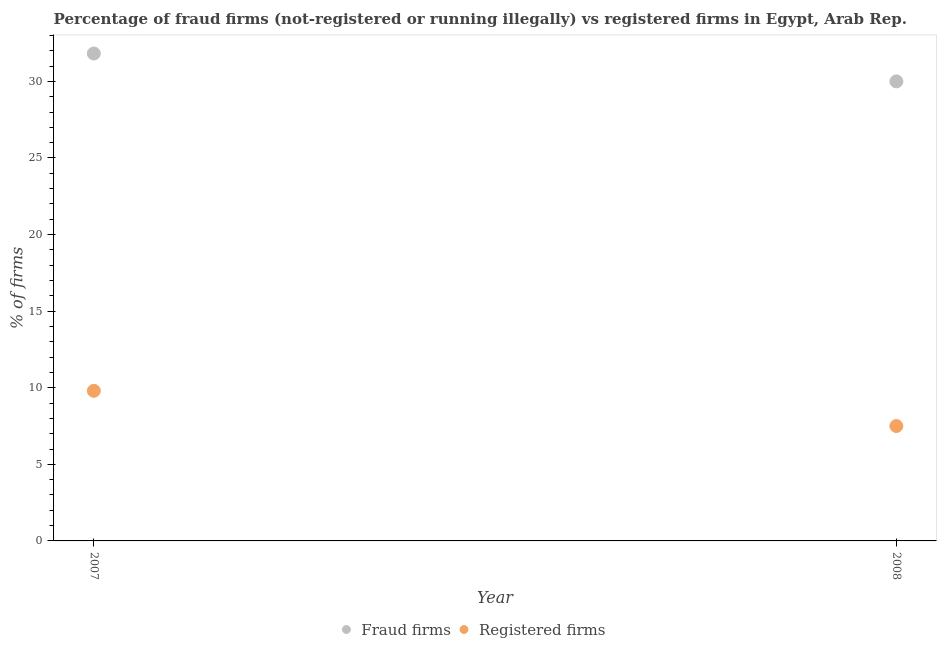How many different coloured dotlines are there?
Your response must be concise. 2. What is the percentage of registered firms in 2007?
Provide a succinct answer. 9.8. Across all years, what is the maximum percentage of fraud firms?
Keep it short and to the point. 31.82. Across all years, what is the minimum percentage of registered firms?
Make the answer very short. 7.5. In which year was the percentage of fraud firms maximum?
Provide a short and direct response. 2007. What is the total percentage of fraud firms in the graph?
Offer a very short reply. 61.82. What is the difference between the percentage of registered firms in 2007 and that in 2008?
Provide a short and direct response. 2.3. What is the difference between the percentage of fraud firms in 2007 and the percentage of registered firms in 2008?
Give a very brief answer. 24.32. What is the average percentage of registered firms per year?
Give a very brief answer. 8.65. In the year 2008, what is the difference between the percentage of fraud firms and percentage of registered firms?
Offer a terse response. 22.5. What is the ratio of the percentage of registered firms in 2007 to that in 2008?
Offer a terse response. 1.31. In how many years, is the percentage of fraud firms greater than the average percentage of fraud firms taken over all years?
Give a very brief answer. 1. Does the percentage of registered firms monotonically increase over the years?
Your answer should be very brief. No. How many dotlines are there?
Give a very brief answer. 2. Are the values on the major ticks of Y-axis written in scientific E-notation?
Provide a short and direct response. No. Does the graph contain grids?
Keep it short and to the point. No. How many legend labels are there?
Offer a very short reply. 2. How are the legend labels stacked?
Offer a terse response. Horizontal. What is the title of the graph?
Give a very brief answer. Percentage of fraud firms (not-registered or running illegally) vs registered firms in Egypt, Arab Rep. What is the label or title of the Y-axis?
Offer a very short reply. % of firms. What is the % of firms in Fraud firms in 2007?
Provide a short and direct response. 31.82. What is the % of firms in Registered firms in 2007?
Provide a succinct answer. 9.8. What is the % of firms in Fraud firms in 2008?
Provide a short and direct response. 30. What is the % of firms in Registered firms in 2008?
Provide a succinct answer. 7.5. Across all years, what is the maximum % of firms of Fraud firms?
Keep it short and to the point. 31.82. Across all years, what is the maximum % of firms in Registered firms?
Your answer should be very brief. 9.8. What is the total % of firms of Fraud firms in the graph?
Your response must be concise. 61.82. What is the total % of firms of Registered firms in the graph?
Offer a terse response. 17.3. What is the difference between the % of firms of Fraud firms in 2007 and that in 2008?
Your response must be concise. 1.82. What is the difference between the % of firms of Fraud firms in 2007 and the % of firms of Registered firms in 2008?
Offer a very short reply. 24.32. What is the average % of firms of Fraud firms per year?
Your answer should be very brief. 30.91. What is the average % of firms in Registered firms per year?
Ensure brevity in your answer.  8.65. In the year 2007, what is the difference between the % of firms of Fraud firms and % of firms of Registered firms?
Your response must be concise. 22.02. What is the ratio of the % of firms in Fraud firms in 2007 to that in 2008?
Offer a very short reply. 1.06. What is the ratio of the % of firms of Registered firms in 2007 to that in 2008?
Provide a short and direct response. 1.31. What is the difference between the highest and the second highest % of firms of Fraud firms?
Ensure brevity in your answer.  1.82. What is the difference between the highest and the lowest % of firms of Fraud firms?
Keep it short and to the point. 1.82. 